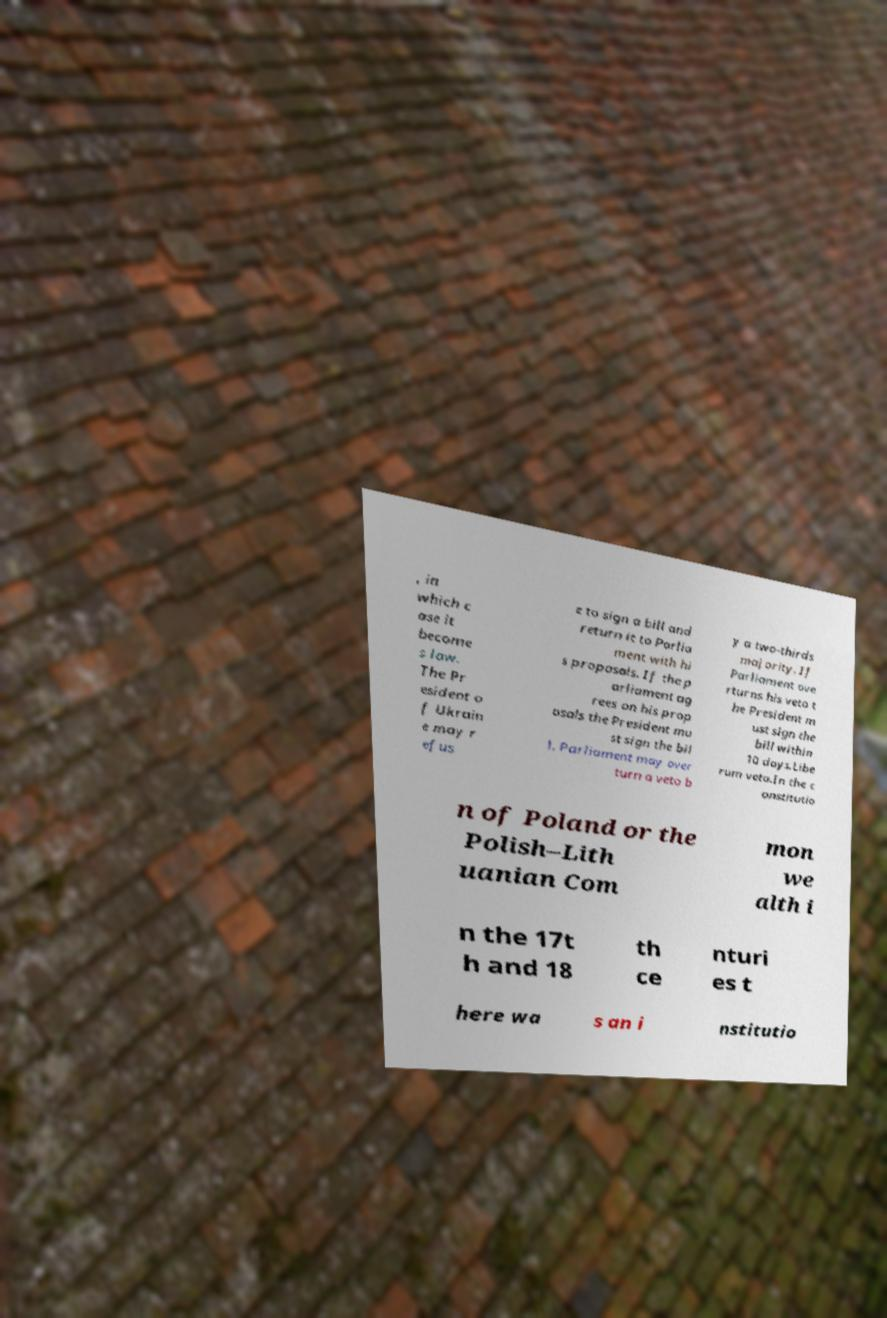What messages or text are displayed in this image? I need them in a readable, typed format. , in which c ase it become s law. The Pr esident o f Ukrain e may r efus e to sign a bill and return it to Parlia ment with hi s proposals. If the p arliament ag rees on his prop osals the President mu st sign the bil l. Parliament may over turn a veto b y a two-thirds majority. If Parliament ove rturns his veto t he President m ust sign the bill within 10 days.Libe rum veto.In the c onstitutio n of Poland or the Polish–Lith uanian Com mon we alth i n the 17t h and 18 th ce nturi es t here wa s an i nstitutio 